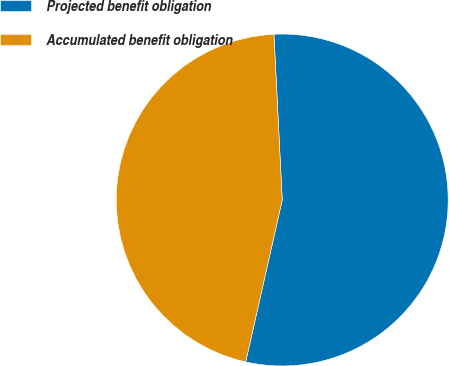<chart> <loc_0><loc_0><loc_500><loc_500><pie_chart><fcel>Projected benefit obligation<fcel>Accumulated benefit obligation<nl><fcel>54.33%<fcel>45.67%<nl></chart> 